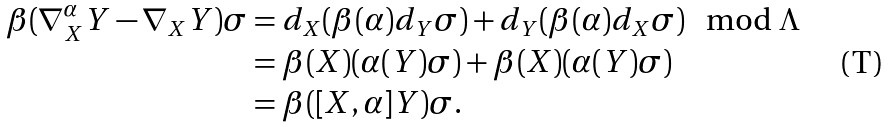Convert formula to latex. <formula><loc_0><loc_0><loc_500><loc_500>\beta ( \nabla ^ { \alpha } _ { X } Y - \nabla _ { X } Y ) \sigma & = d _ { X } ( \beta ( \alpha ) d _ { Y } \sigma ) + d _ { Y } ( \beta ( \alpha ) d _ { X } \sigma ) \mod \Lambda \\ & = \beta ( X ) ( \alpha ( Y ) \sigma ) + \beta ( X ) ( \alpha ( Y ) \sigma ) \\ & = \beta ( [ X , \alpha ] Y ) \sigma .</formula> 